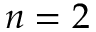Convert formula to latex. <formula><loc_0><loc_0><loc_500><loc_500>n = 2</formula> 